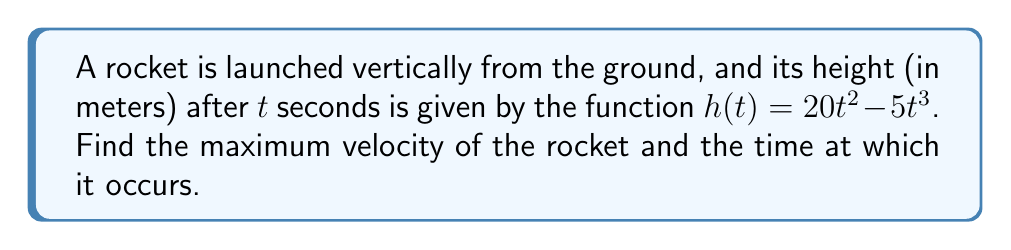What is the answer to this math problem? Let's approach this step-by-step:

1) First, we need to find the velocity function. Velocity is the first derivative of position with respect to time:

   $v(t) = h'(t) = \frac{d}{dt}(20t^2 - 5t^3) = 40t - 15t^2$

2) To find the maximum velocity, we need to find where the derivative of the velocity function equals zero. The derivative of velocity is acceleration:

   $a(t) = v'(t) = \frac{d}{dt}(40t - 15t^2) = 40 - 30t$

3) Set this equal to zero and solve for t:

   $40 - 30t = 0$
   $-30t = -40$
   $t = \frac{40}{30} = \frac{4}{3}$

4) To confirm this is a maximum (not a minimum), we can check the second derivative (which is the derivative of acceleration):

   $a'(t) = -30$

   Since this is negative, we confirm that $t = \frac{4}{3}$ gives a maximum velocity.

5) Now, let's calculate the maximum velocity by plugging $t = \frac{4}{3}$ into our velocity function:

   $v(\frac{4}{3}) = 40(\frac{4}{3}) - 15(\frac{4}{3})^2$
                  $= \frac{160}{3} - 15(\frac{16}{9})$
                  $= \frac{160}{3} - \frac{240}{9}$
                  $= \frac{160}{3} - \frac{80}{3}$
                  $= \frac{80}{3}$
                  $\approx 26.67$ m/s

Therefore, the maximum velocity is $\frac{80}{3}$ m/s and it occurs at $t = \frac{4}{3}$ seconds.
Answer: $\frac{80}{3}$ m/s at $t = \frac{4}{3}$ s 